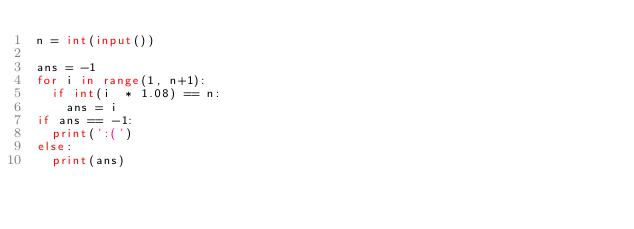Convert code to text. <code><loc_0><loc_0><loc_500><loc_500><_Python_>n = int(input())
 
ans = -1
for i in range(1, n+1):
  if int(i  * 1.08) == n:
    ans = i
if ans == -1:
  print(':(')
else:
  print(ans)</code> 